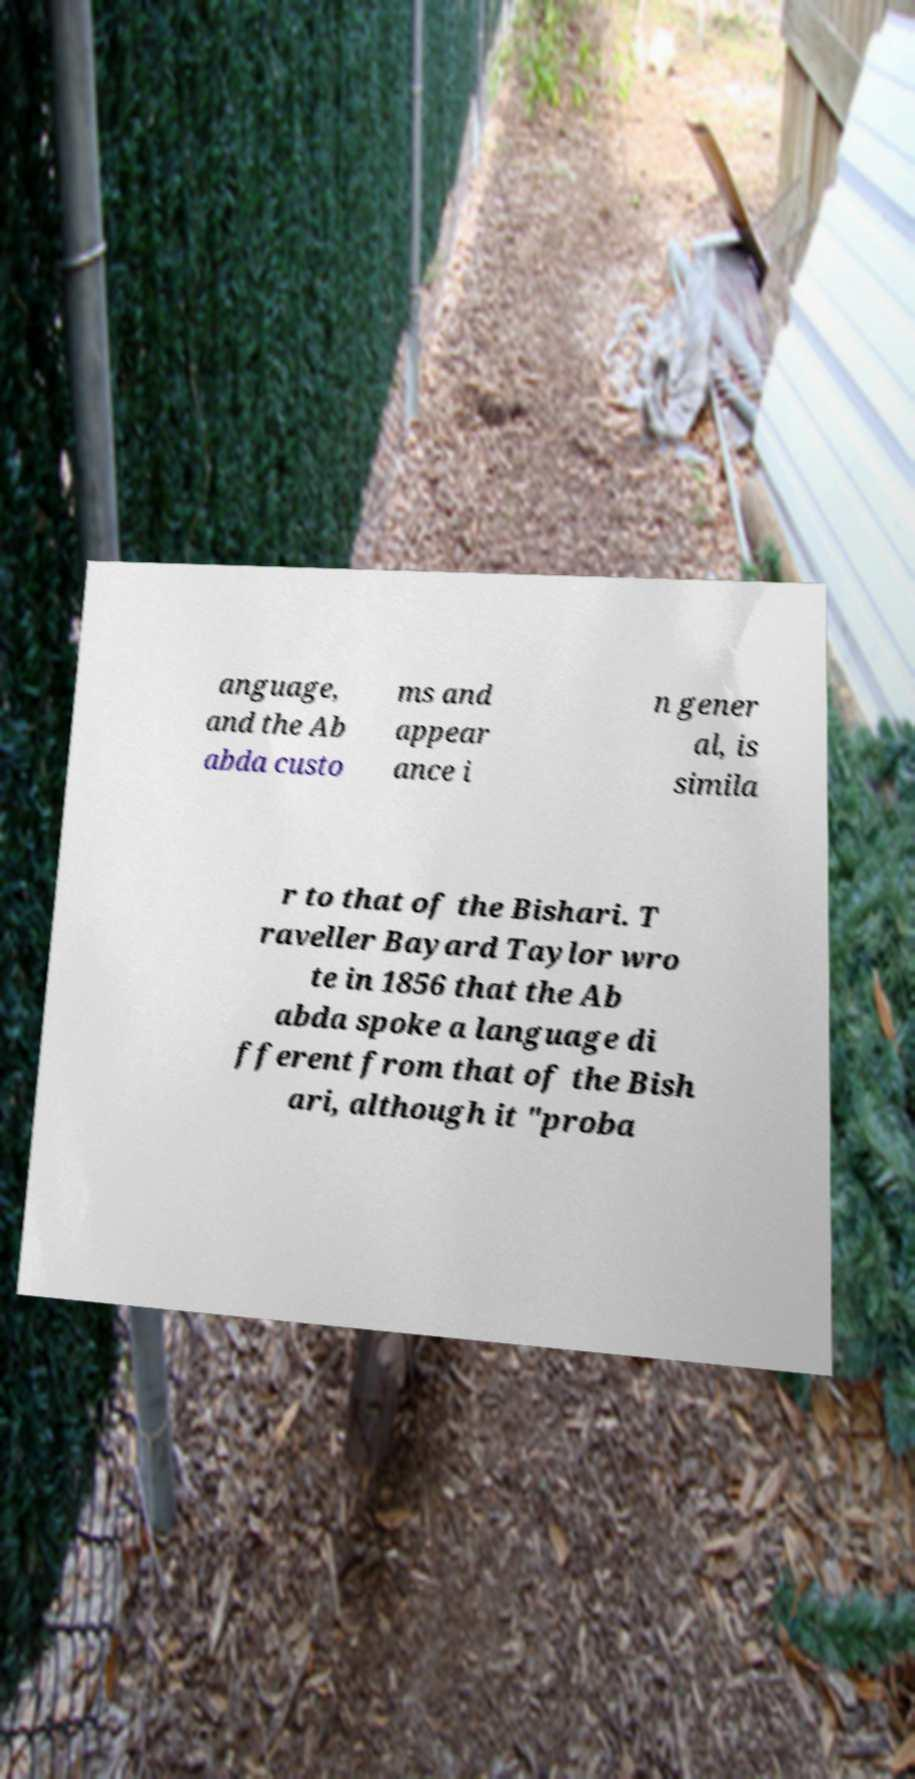What messages or text are displayed in this image? I need them in a readable, typed format. anguage, and the Ab abda custo ms and appear ance i n gener al, is simila r to that of the Bishari. T raveller Bayard Taylor wro te in 1856 that the Ab abda spoke a language di fferent from that of the Bish ari, although it "proba 